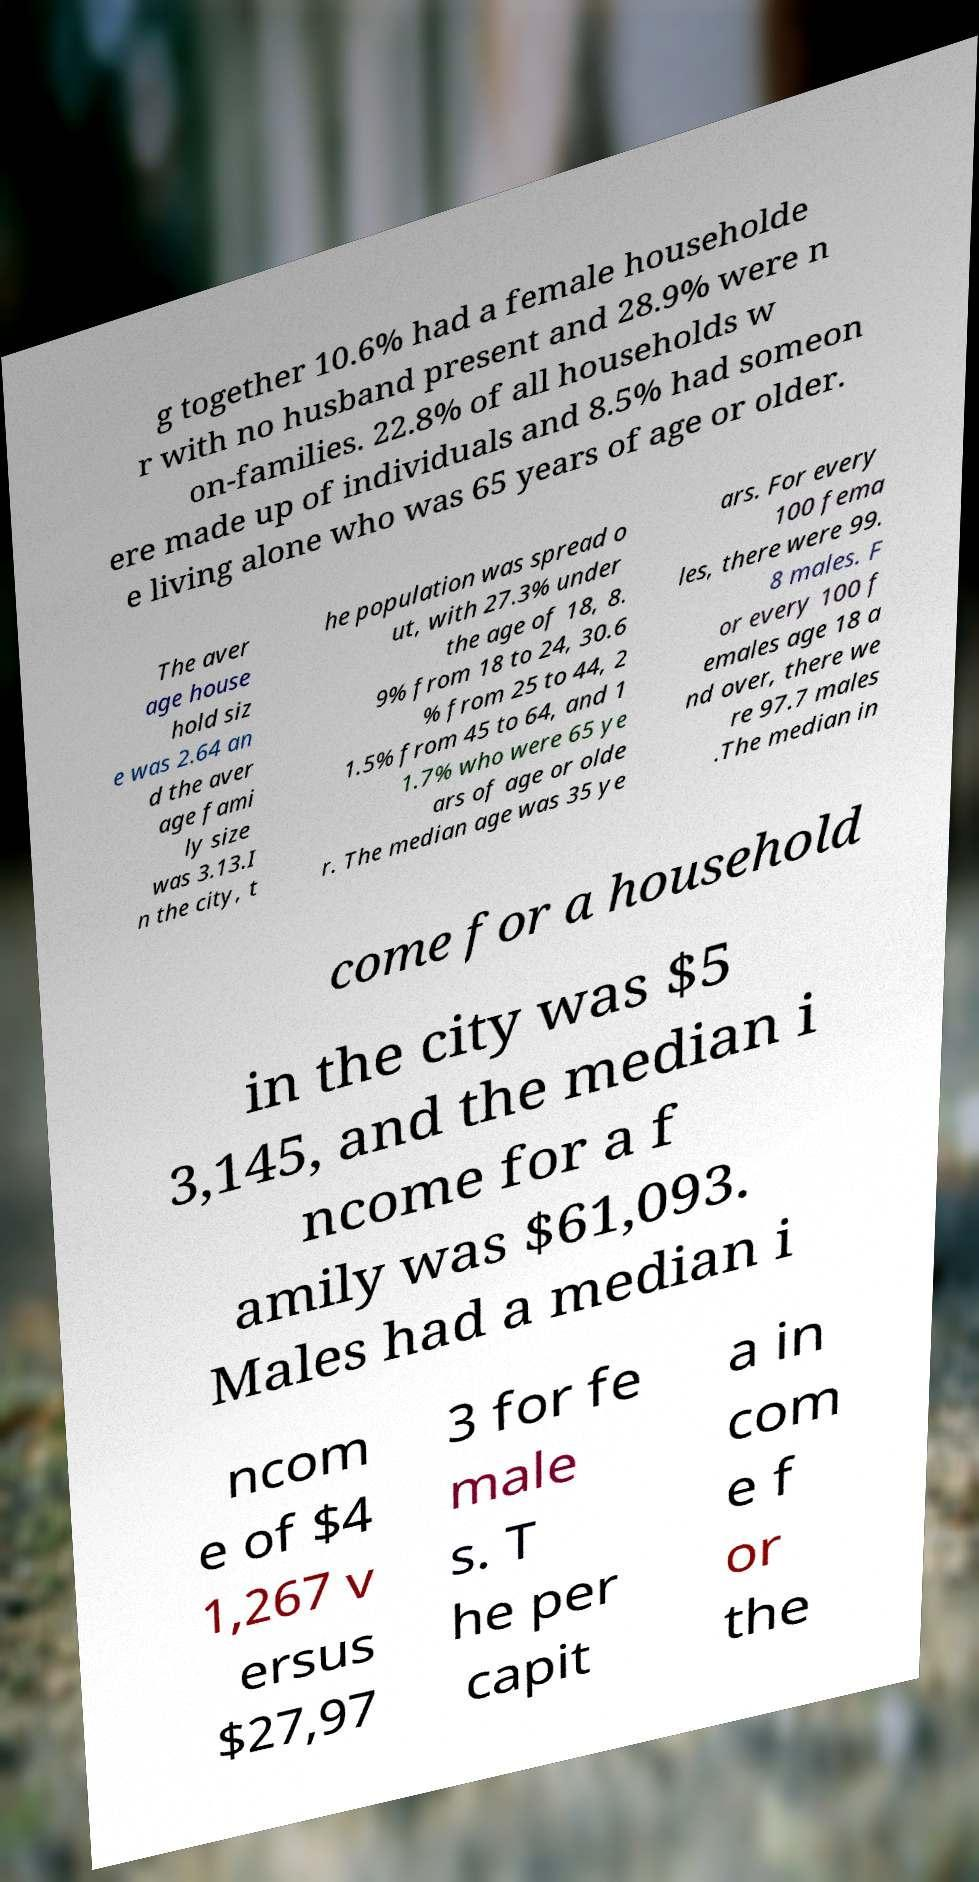Please identify and transcribe the text found in this image. g together 10.6% had a female householde r with no husband present and 28.9% were n on-families. 22.8% of all households w ere made up of individuals and 8.5% had someon e living alone who was 65 years of age or older. The aver age house hold siz e was 2.64 an d the aver age fami ly size was 3.13.I n the city, t he population was spread o ut, with 27.3% under the age of 18, 8. 9% from 18 to 24, 30.6 % from 25 to 44, 2 1.5% from 45 to 64, and 1 1.7% who were 65 ye ars of age or olde r. The median age was 35 ye ars. For every 100 fema les, there were 99. 8 males. F or every 100 f emales age 18 a nd over, there we re 97.7 males .The median in come for a household in the city was $5 3,145, and the median i ncome for a f amily was $61,093. Males had a median i ncom e of $4 1,267 v ersus $27,97 3 for fe male s. T he per capit a in com e f or the 